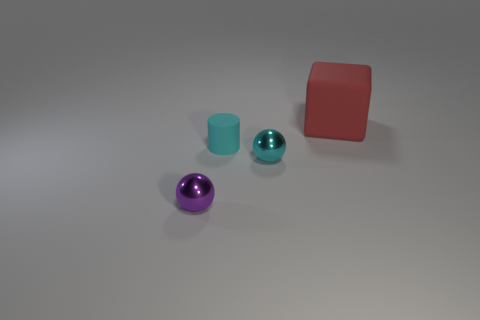What is the size of the cyan object that is the same shape as the tiny purple object?
Your response must be concise. Small. Are there any other things that are the same size as the cylinder?
Provide a succinct answer. Yes. There is a shiny sphere that is left of the cyan cylinder; what is its color?
Provide a short and direct response. Purple. What material is the tiny object behind the metallic sphere that is right of the metallic sphere in front of the cyan sphere made of?
Keep it short and to the point. Rubber. How big is the cyan rubber cylinder that is right of the tiny metal object left of the cyan matte cylinder?
Ensure brevity in your answer.  Small. What is the color of the other object that is the same shape as the small purple object?
Provide a succinct answer. Cyan. How many metallic balls are the same color as the cylinder?
Ensure brevity in your answer.  1. Is the purple shiny sphere the same size as the cyan cylinder?
Provide a short and direct response. Yes. What is the small purple ball made of?
Your response must be concise. Metal. What is the color of the small object that is made of the same material as the big block?
Offer a terse response. Cyan. 